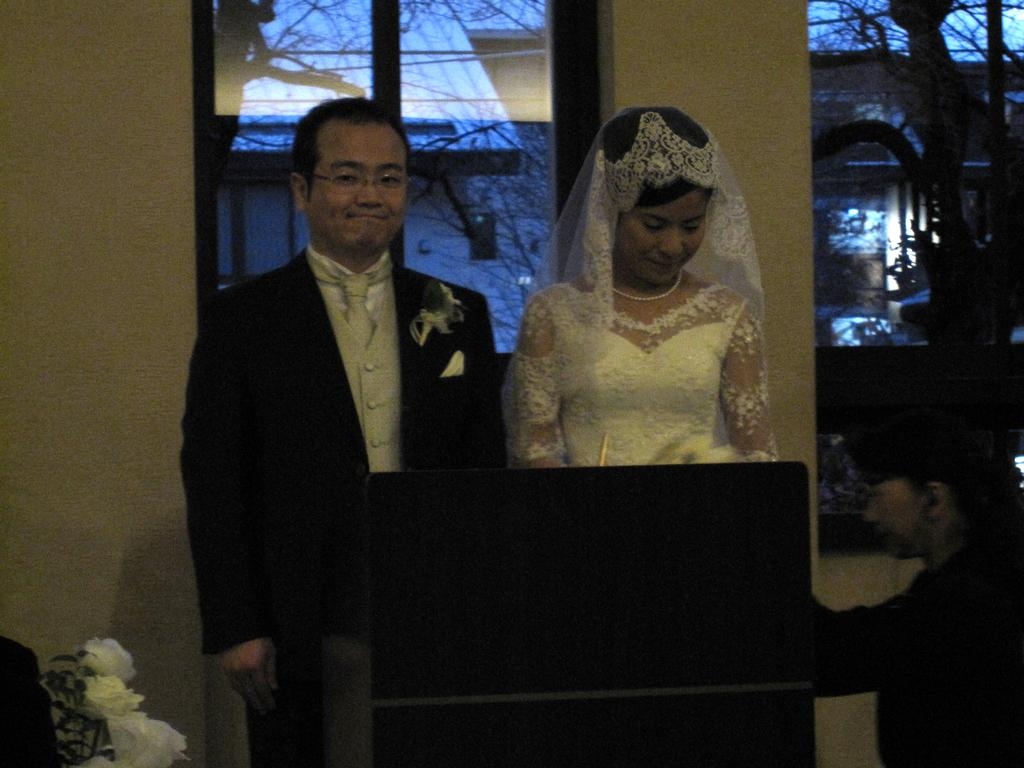Who are the two people in the middle of the image? There is a couple in the middle of the image. What is the position of the third person in the image? There is a person on the right side of the image. What can be seen in the background of the image? There is a wall and a window in the background of the image. What type of salt is being used by the couple in the image? There is no salt present in the image. What sound can be heard coming from the window in the image? There is no sound mentioned or depicted in the image. 